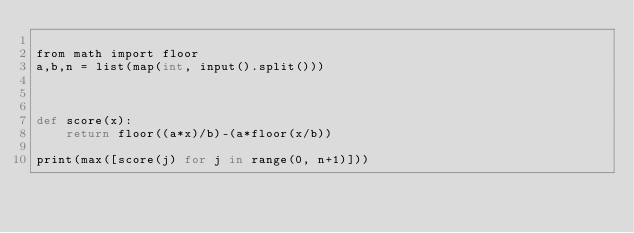Convert code to text. <code><loc_0><loc_0><loc_500><loc_500><_Cython_>
from math import floor
a,b,n = list(map(int, input().split()))



def score(x):
    return floor((a*x)/b)-(a*floor(x/b))

print(max([score(j) for j in range(0, n+1)]))
</code> 